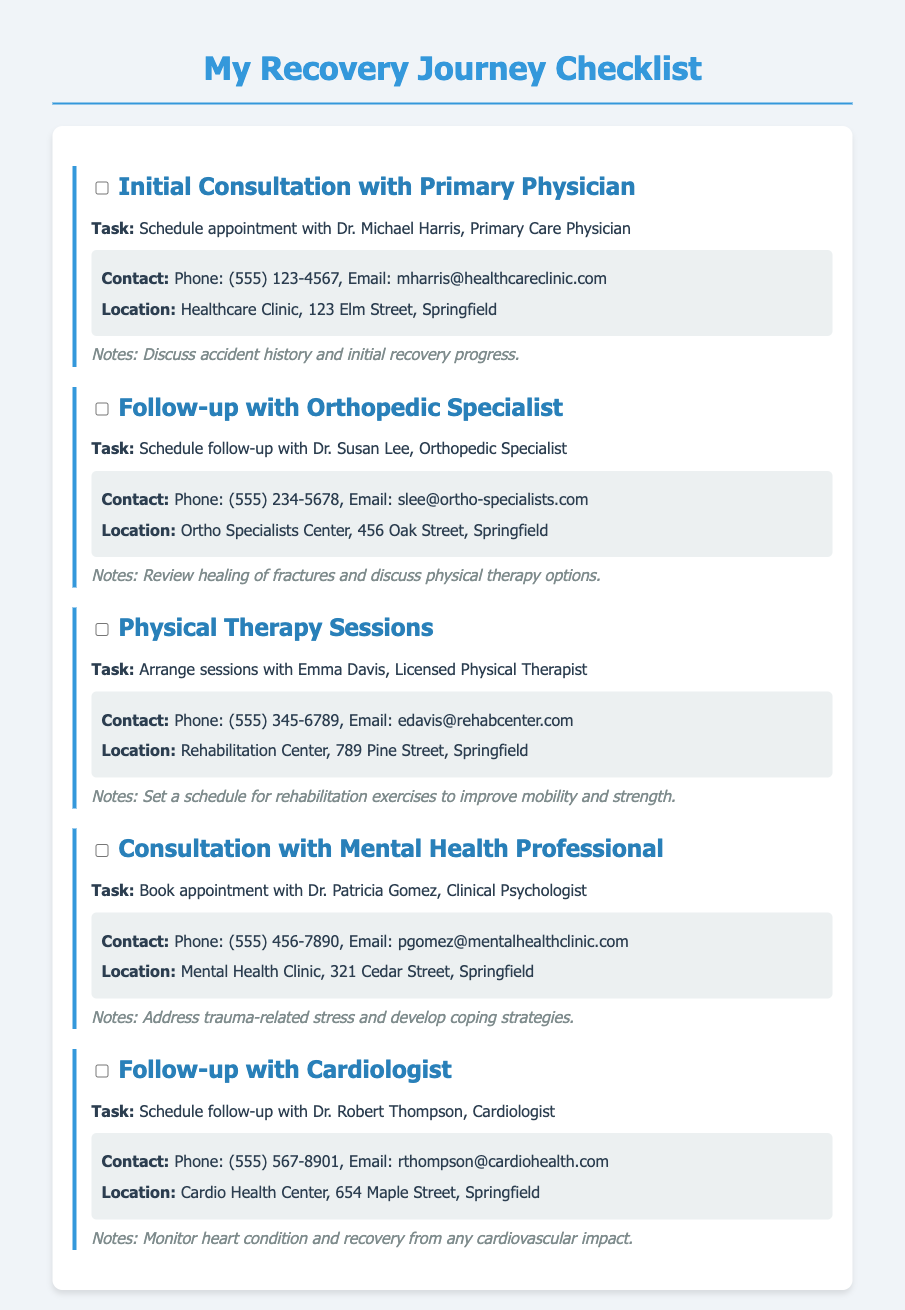What is the name of the primary physician? The document specifies Dr. Michael Harris as the primary physician to be consulted.
Answer: Dr. Michael Harris What is the email address of the orthopedic specialist? The email for Dr. Susan Lee, the orthopedic specialist, is provided in the document.
Answer: slee@ortho-specialists.com How many physical therapy sessions are mentioned? The document does not specify a number of sessions, only that they need to be arranged.
Answer: Not specified What is the location of the mental health clinic? The document lists the address for the Mental Health Clinic, which is essential for locating it.
Answer: 321 Cedar Street, Springfield Which professional is tasked with reviewing the healing of fractures? The follow-up with the orthopedic specialist, Dr. Susan Lee, is focused on this task as mentioned in the document.
Answer: Dr. Susan Lee What is the contact phone number for the cardiologist? The document lists the contact details for Dr. Robert Thompson, the cardiologist, which includes his phone number.
Answer: (555) 567-8901 What is the purpose of consulting with the mental health professional? The document notes that the appointment is aimed at addressing trauma-related stress and coping strategies.
Answer: Trauma-related stress Who is responsible for arranging physical therapy sessions? The document mentions Emma Davis, the Licensed Physical Therapist, as the contact for arranging sessions.
Answer: Emma Davis What notes are provided regarding the initial consultation? The notes indicate that the initial consultation will discuss accident history and recovery progress.
Answer: Accident history and initial recovery progress 